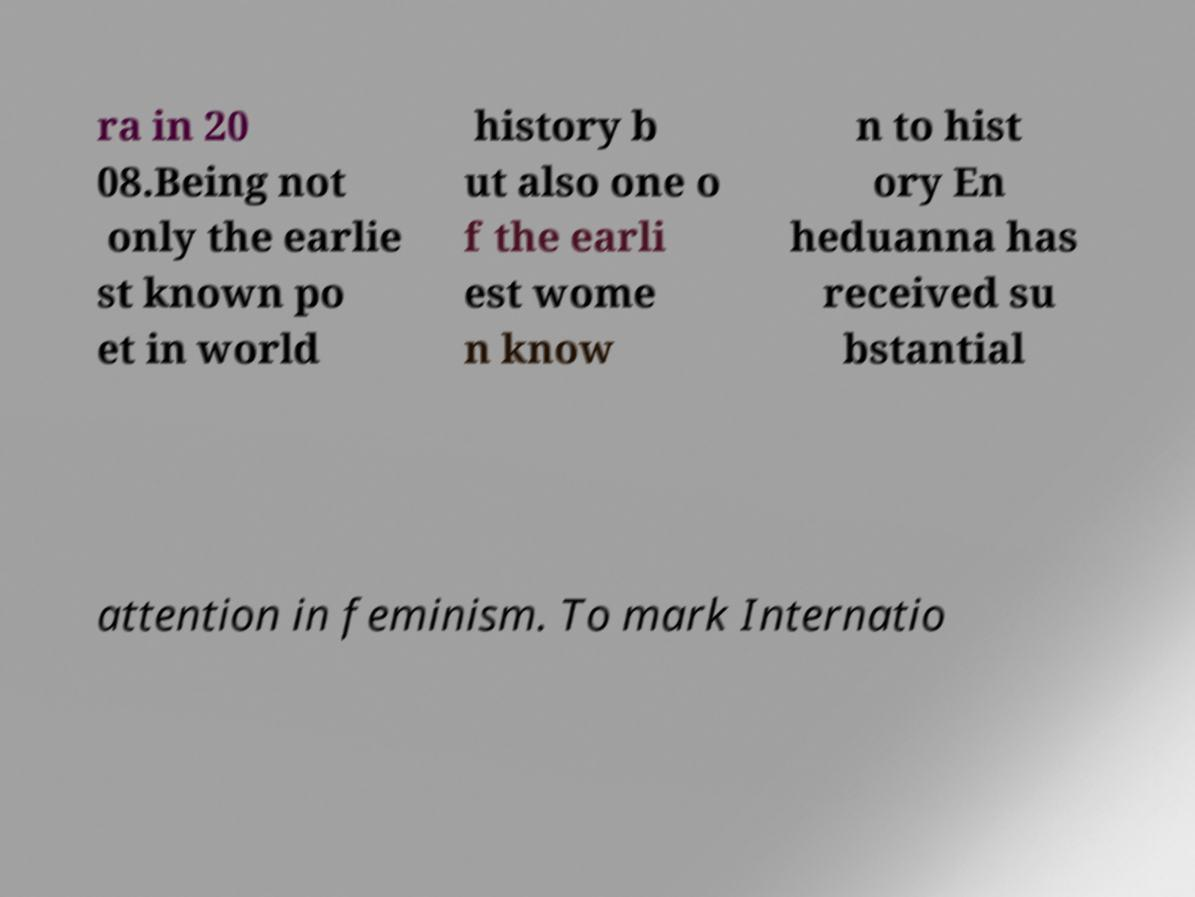Please identify and transcribe the text found in this image. ra in 20 08.Being not only the earlie st known po et in world history b ut also one o f the earli est wome n know n to hist ory En heduanna has received su bstantial attention in feminism. To mark Internatio 